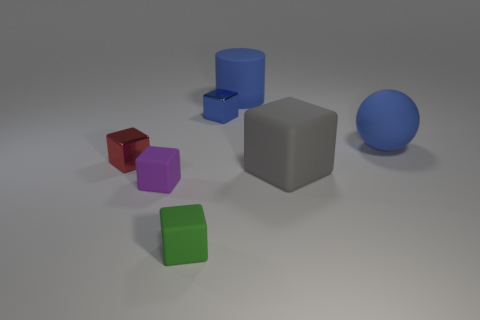Subtract all gray blocks. How many blocks are left? 4 Subtract 2 cubes. How many cubes are left? 3 Subtract all blue blocks. How many blocks are left? 4 Subtract all green cubes. Subtract all gray spheres. How many cubes are left? 4 Add 2 large cyan objects. How many objects exist? 9 Subtract all cylinders. How many objects are left? 6 Subtract all blue metal things. Subtract all rubber cylinders. How many objects are left? 5 Add 1 large gray objects. How many large gray objects are left? 2 Add 2 tiny purple metallic things. How many tiny purple metallic things exist? 2 Subtract 0 green balls. How many objects are left? 7 